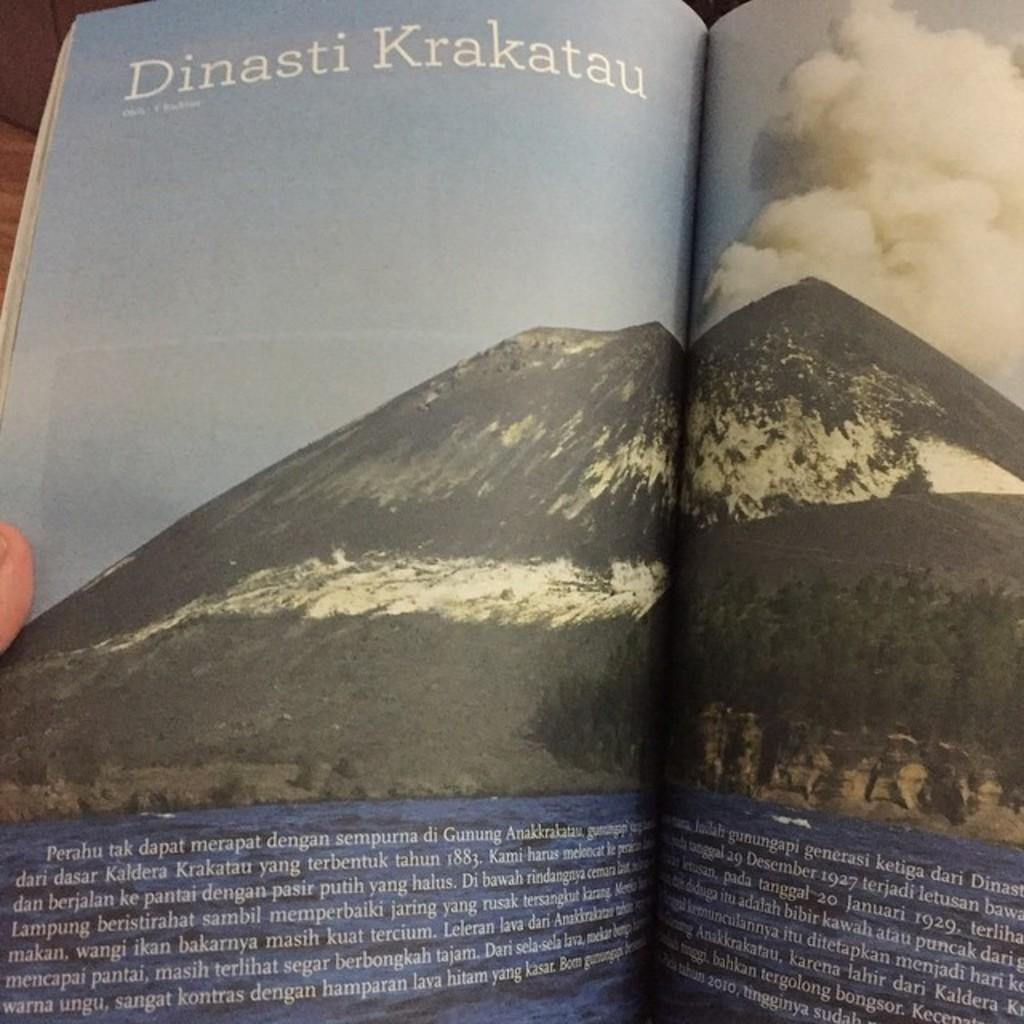<image>
Share a concise interpretation of the image provided. An article from a magazine titled Dinasti Krakatau. 